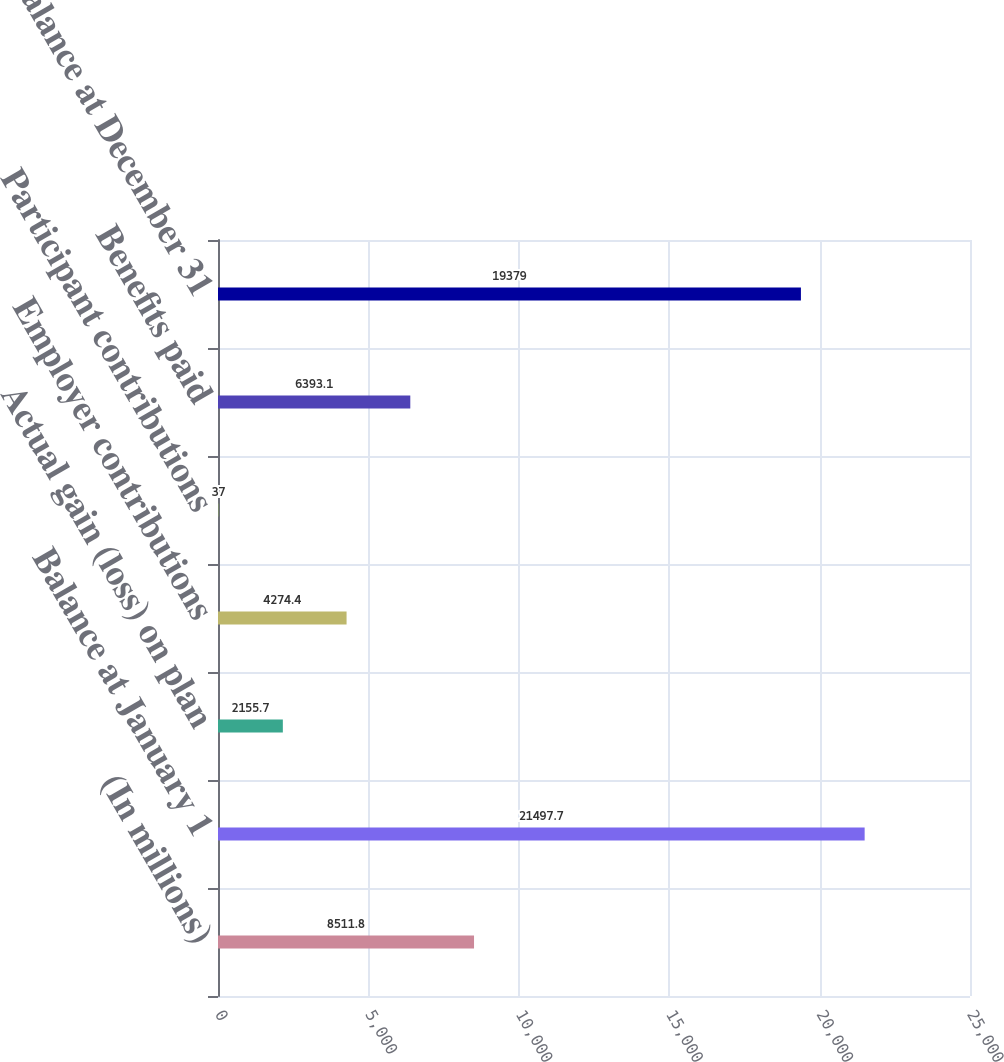Convert chart. <chart><loc_0><loc_0><loc_500><loc_500><bar_chart><fcel>(In millions)<fcel>Balance at January 1<fcel>Actual gain (loss) on plan<fcel>Employer contributions<fcel>Participant contributions<fcel>Benefits paid<fcel>Balance at December 31<nl><fcel>8511.8<fcel>21497.7<fcel>2155.7<fcel>4274.4<fcel>37<fcel>6393.1<fcel>19379<nl></chart> 